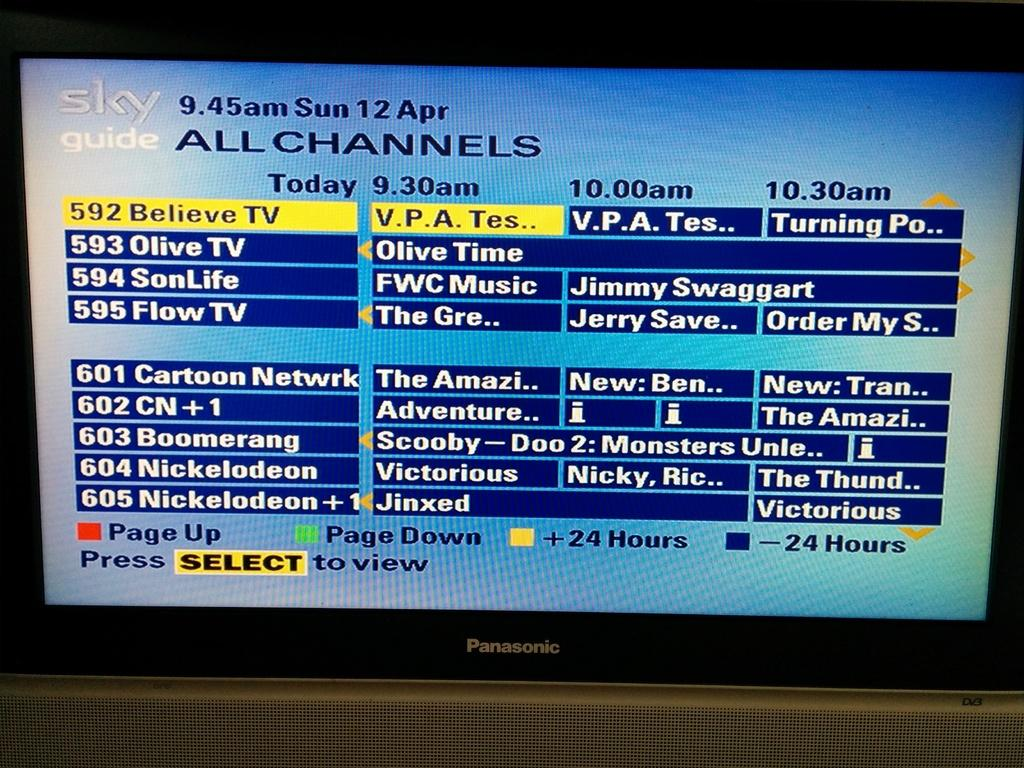<image>
Share a concise interpretation of the image provided. A Panasonic screen with Sky channels and information. 